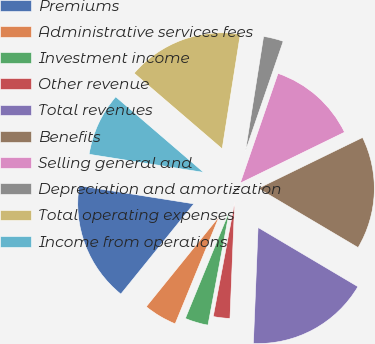<chart> <loc_0><loc_0><loc_500><loc_500><pie_chart><fcel>Premiums<fcel>Administrative services fees<fcel>Investment income<fcel>Other revenue<fcel>Total revenues<fcel>Benefits<fcel>Selling general and<fcel>Depreciation and amortization<fcel>Total operating expenses<fcel>Income from operations<nl><fcel>16.67%<fcel>4.63%<fcel>3.24%<fcel>2.31%<fcel>17.13%<fcel>15.74%<fcel>12.5%<fcel>2.78%<fcel>16.2%<fcel>8.8%<nl></chart> 